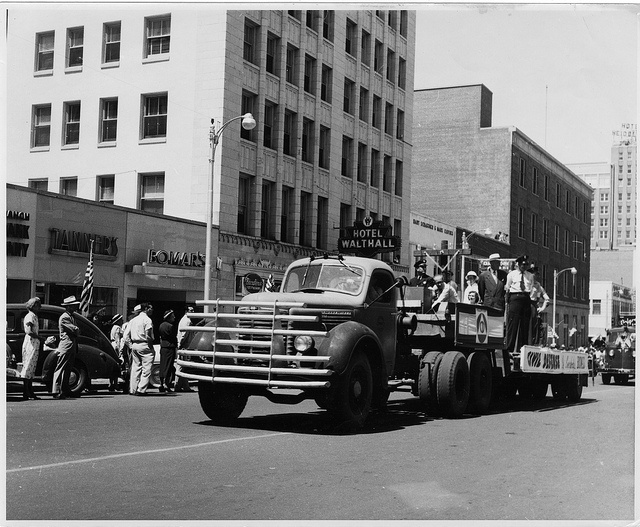Describe the objects in this image and their specific colors. I can see truck in white, black, gray, darkgray, and lightgray tones, car in white, black, gray, and gainsboro tones, people in white, black, gainsboro, gray, and darkgray tones, people in white, lightgray, black, darkgray, and gray tones, and people in white, black, gray, lightgray, and darkgray tones in this image. 